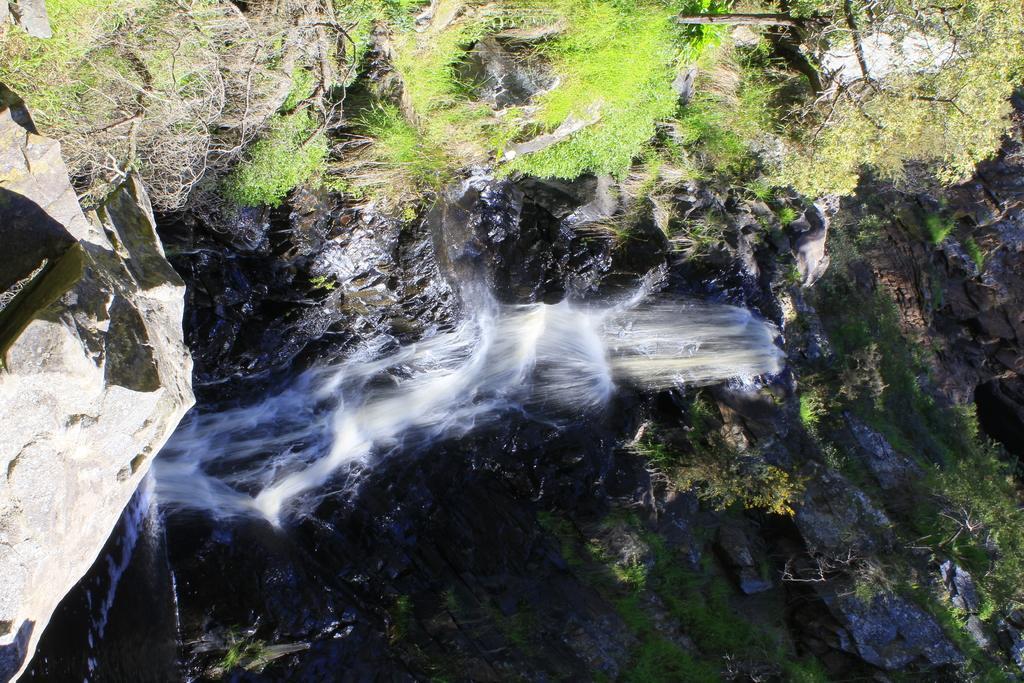In one or two sentences, can you explain what this image depicts? In this image I can see waterfalls, I can also see rocks. Background I can see grass and trees in green color. 